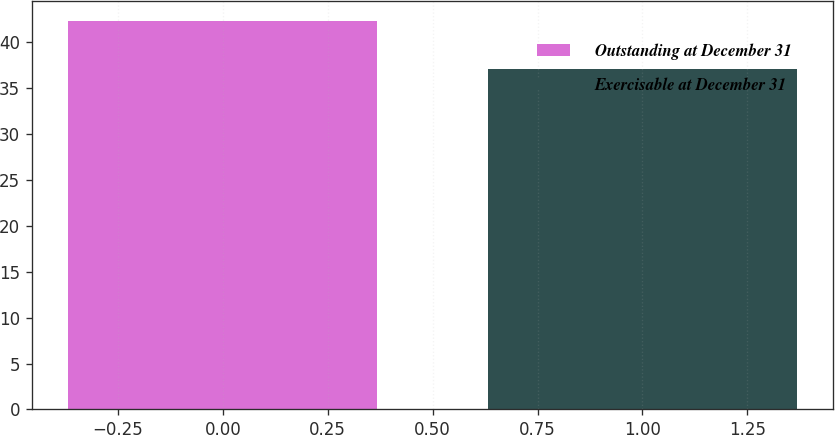Convert chart to OTSL. <chart><loc_0><loc_0><loc_500><loc_500><bar_chart><fcel>Outstanding at December 31<fcel>Exercisable at December 31<nl><fcel>42.32<fcel>37.09<nl></chart> 